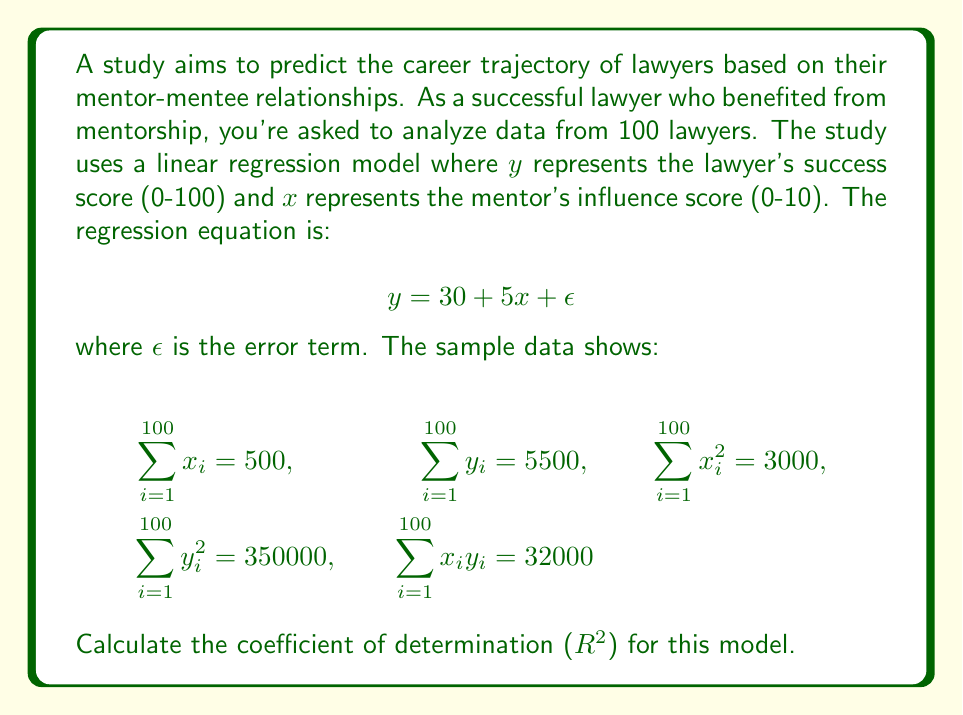Teach me how to tackle this problem. To calculate the coefficient of determination ($R^2$), we'll follow these steps:

1. Calculate the mean values of $x$ and $y$:
   $\bar{x} = \frac{\sum x_i}{n} = \frac{500}{100} = 5$
   $\bar{y} = \frac{\sum y_i}{n} = \frac{5500}{100} = 55$

2. Calculate $SS_{xx}$, $SS_{yy}$, and $SS_{xy}$:
   $SS_{xx} = \sum x_i^2 - n\bar{x}^2 = 3000 - 100(5^2) = 3000 - 2500 = 500$
   $SS_{yy} = \sum y_i^2 - n\bar{y}^2 = 350000 - 100(55^2) = 350000 - 302500 = 47500$
   $SS_{xy} = \sum x_iy_i - n\bar{x}\bar{y} = 32000 - 100(5)(55) = 32000 - 27500 = 4500$

3. Calculate the slope ($b$) and y-intercept ($a$) of the regression line:
   $b = \frac{SS_{xy}}{SS_{xx}} = \frac{4500}{500} = 9$
   $a = \bar{y} - b\bar{x} = 55 - 9(5) = 10$

4. Calculate the total sum of squares ($SS_T$) and the regression sum of squares ($SS_R$):
   $SS_T = SS_{yy} = 47500$
   $SS_R = b \cdot SS_{xy} = 9 \cdot 4500 = 40500$

5. Calculate $R^2$:
   $R^2 = \frac{SS_R}{SS_T} = \frac{40500}{47500} = 0.8526$

Therefore, the coefficient of determination ($R^2$) for this model is 0.8526 or 85.26%.
Answer: 0.8526 